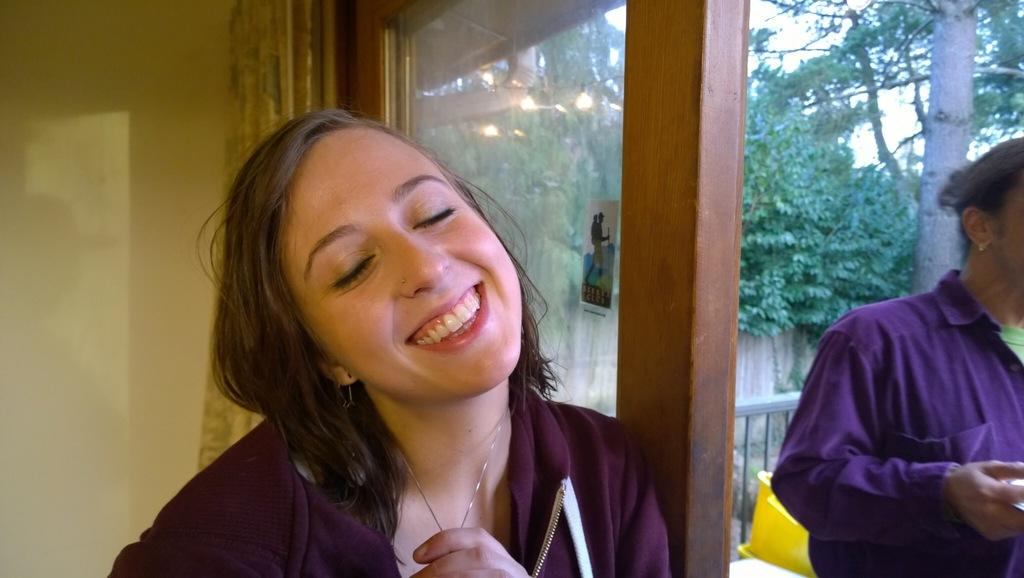What can be seen in the image involving people? There are people (a couple) standing in the image. What type of natural elements are present in the image? There are trees visible in the image. What type of indoor element can be seen in the image? There is a curtain in the image. What type of development is taking place in the image? There is no development project or construction visible in the image; it primarily features people and natural elements. 